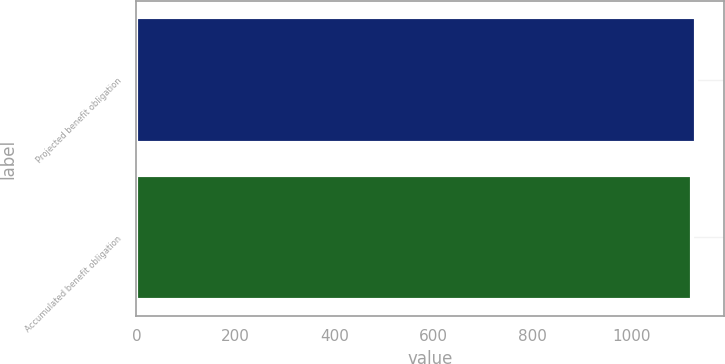Convert chart. <chart><loc_0><loc_0><loc_500><loc_500><bar_chart><fcel>Projected benefit obligation<fcel>Accumulated benefit obligation<nl><fcel>1131<fcel>1122<nl></chart> 